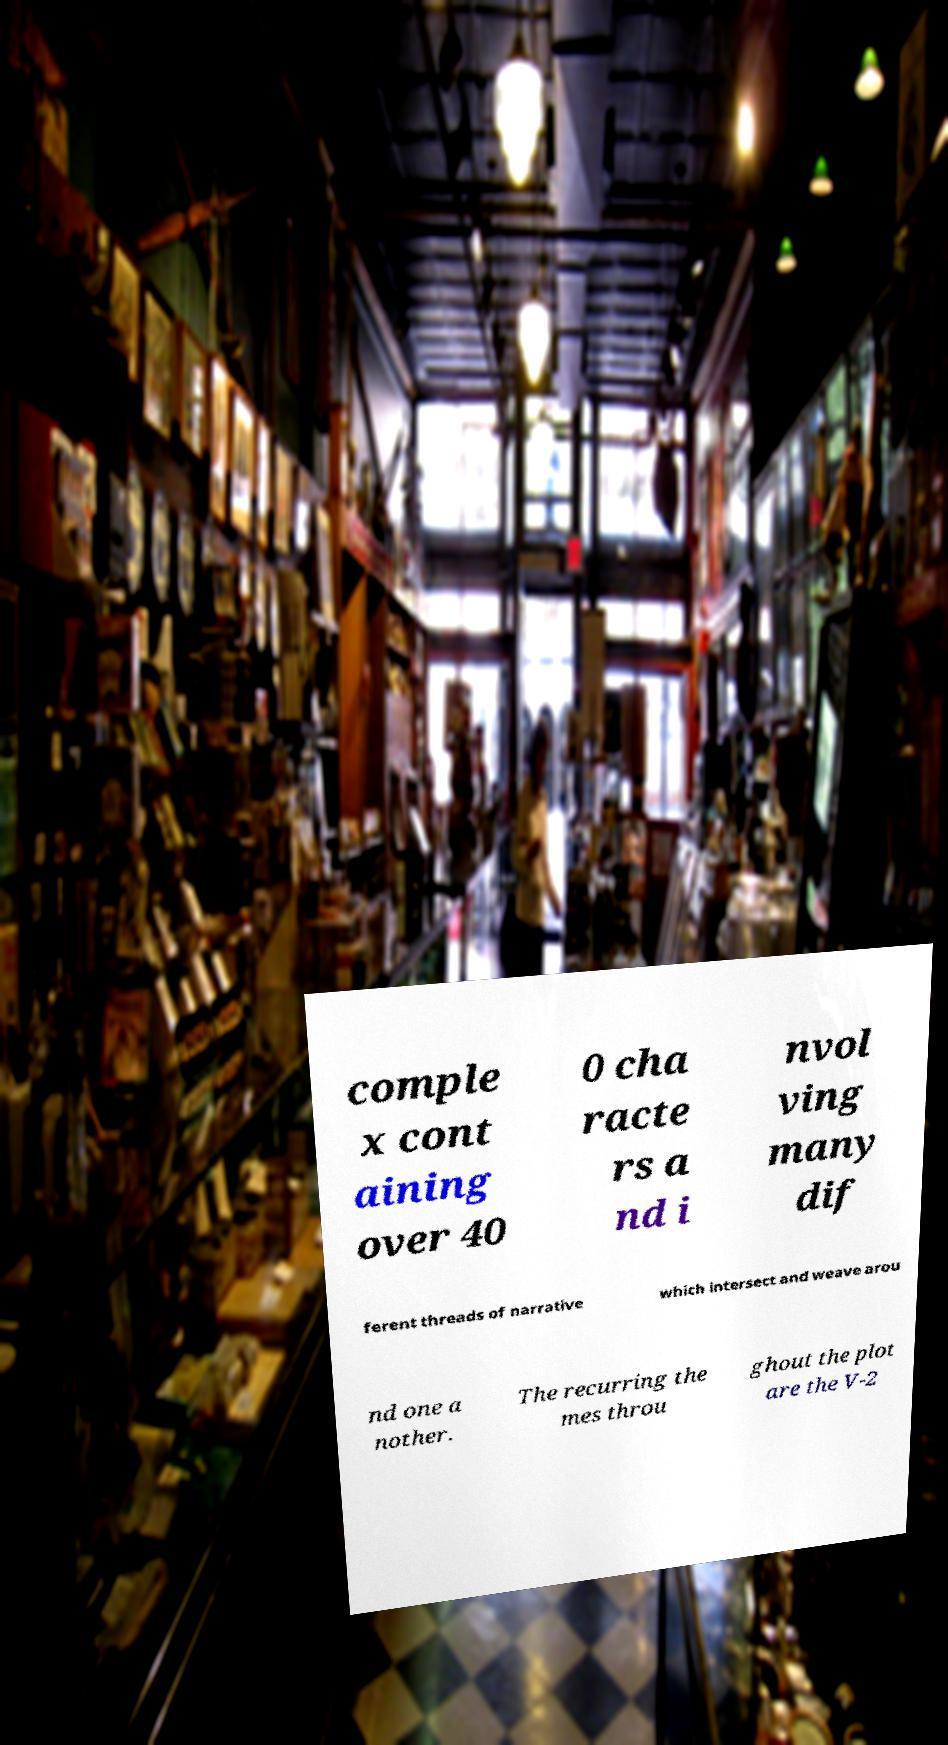Can you read and provide the text displayed in the image?This photo seems to have some interesting text. Can you extract and type it out for me? comple x cont aining over 40 0 cha racte rs a nd i nvol ving many dif ferent threads of narrative which intersect and weave arou nd one a nother. The recurring the mes throu ghout the plot are the V-2 